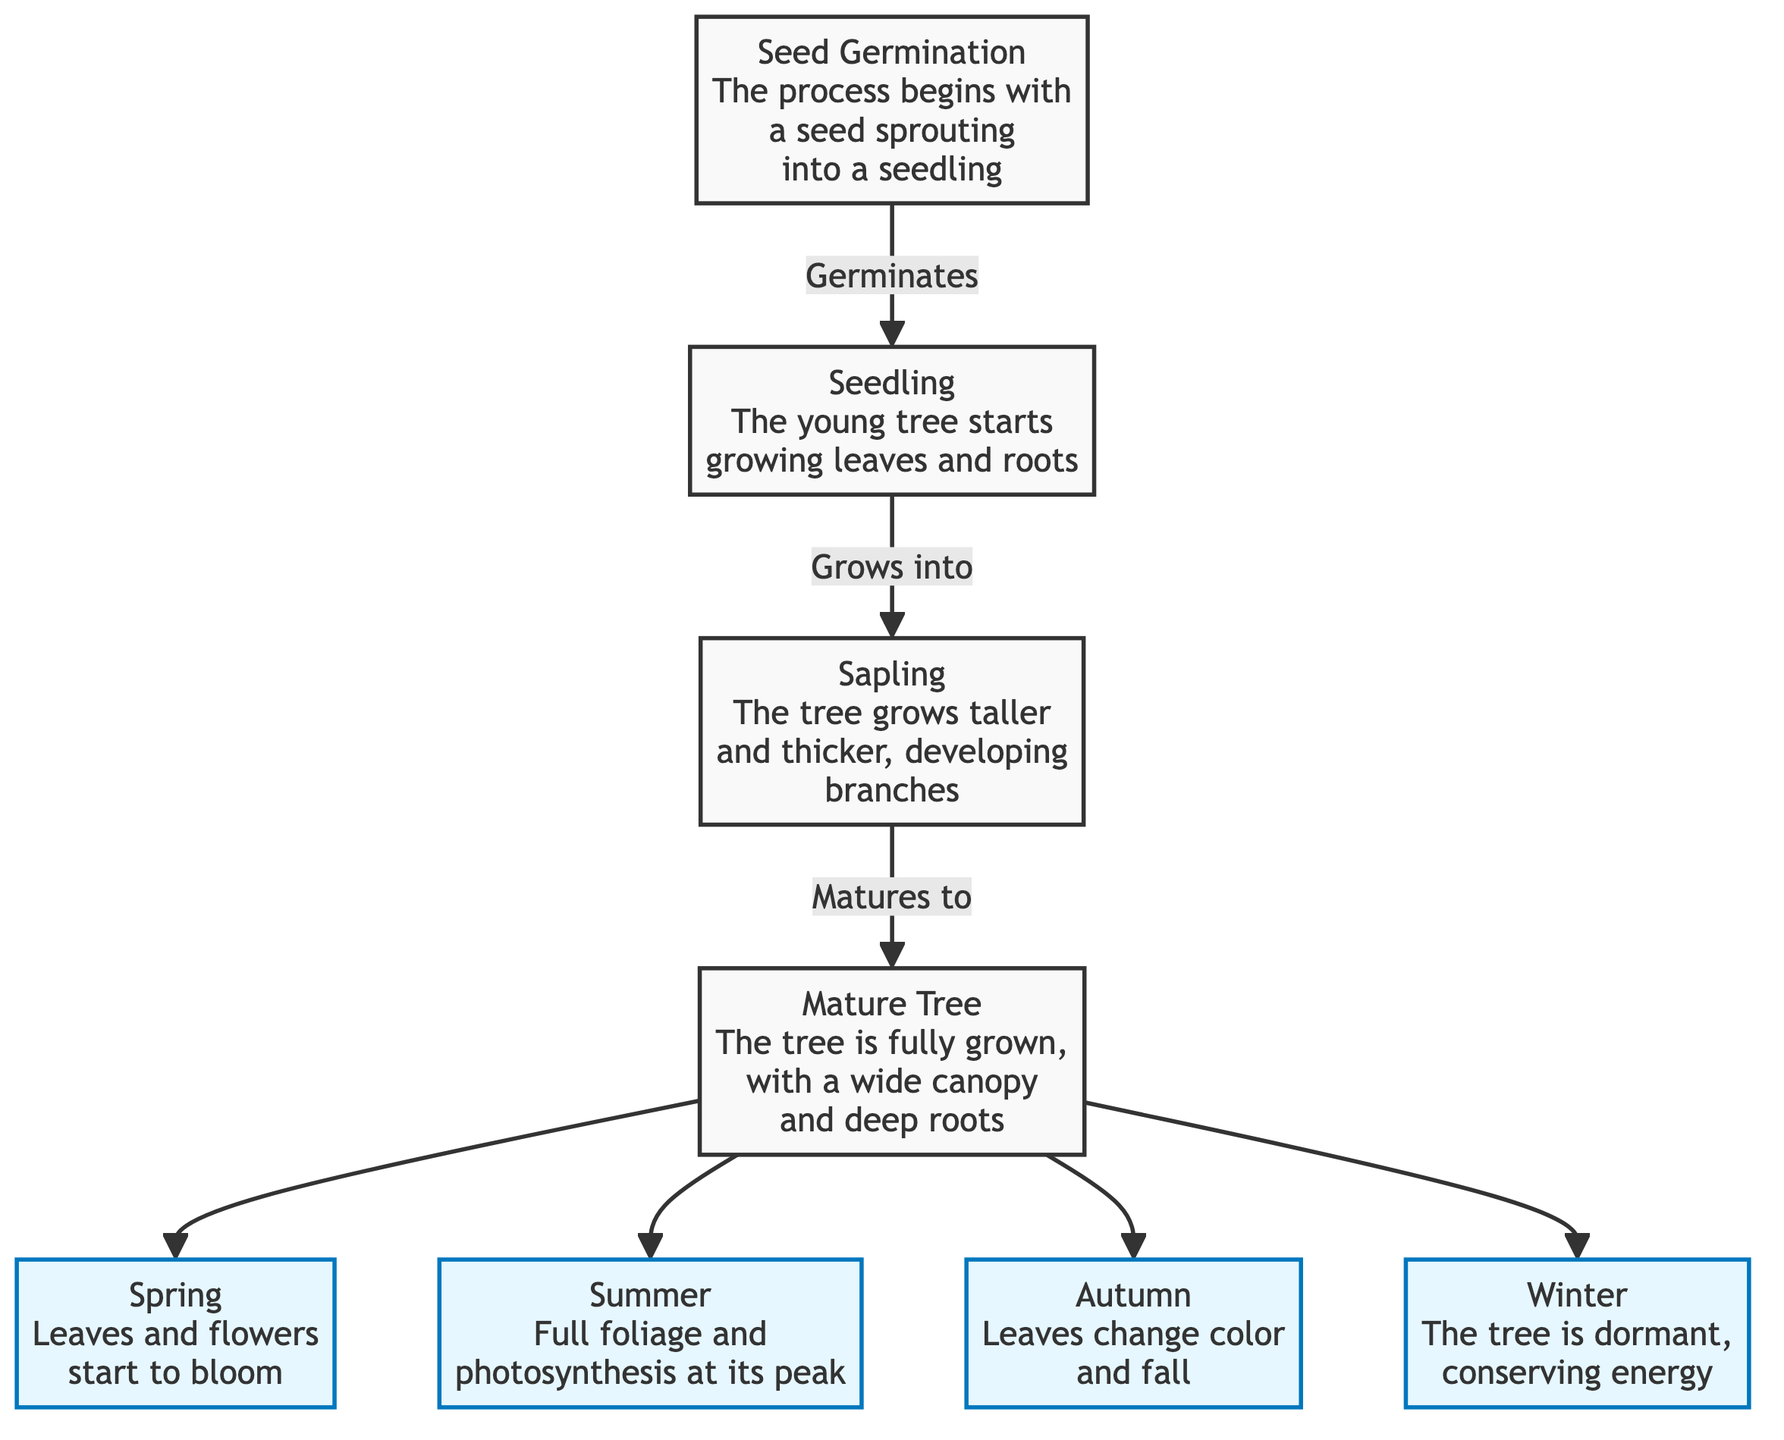What is the first stage in the tree life cycle? According to the diagram, the first stage is labeled 'Seed Germination,' which indicates the process by which a seed sprouts into a seedling.
Answer: Seed Germination How many seasonal stages does the mature tree go through? The diagram shows four seasonal stages branching out from the mature tree: Spring, Summer, Autumn, and Winter. Therefore, the count of seasonal stages is four.
Answer: Four What happens to the leaves during autumn? The annotation for autumn states that 'Leaves change color and fall,' detailing a specific seasonal change associated with the mature tree.
Answer: Leaves change color and fall What is the relationship between sapling and mature tree? The diagram connects sapling to mature tree with the label 'Matures to,' indicating the growth progression from a sapling to a fully grown mature tree.
Answer: Matures to In which season does photosynthesis reach its peak? The summer stage labeled in the diagram states that photosynthesis is at its peak during that season, indicating its significance in the tree's growth.
Answer: Summer What stage follows the seedling? The diagram indicates that 'Sapling' is the next stage that follows seedling, showing the progression in the tree's life cycle.
Answer: Sapling How does the tree conserve energy? The winter stage in the diagram describes that the tree is dormant during winter, implying it conserves energy during this period.
Answer: Dormant, conserving energy What stage is characterized by a wide canopy? The mature tree stage is characterized in the diagram by having a 'wide canopy,' indicating its fully developed form.
Answer: Mature Tree Which season involves blooming leaves and flowers? The diagram specifies that in the spring season, 'Leaves and flowers start to bloom,' highlighting the activities during that time of year.
Answer: Spring 